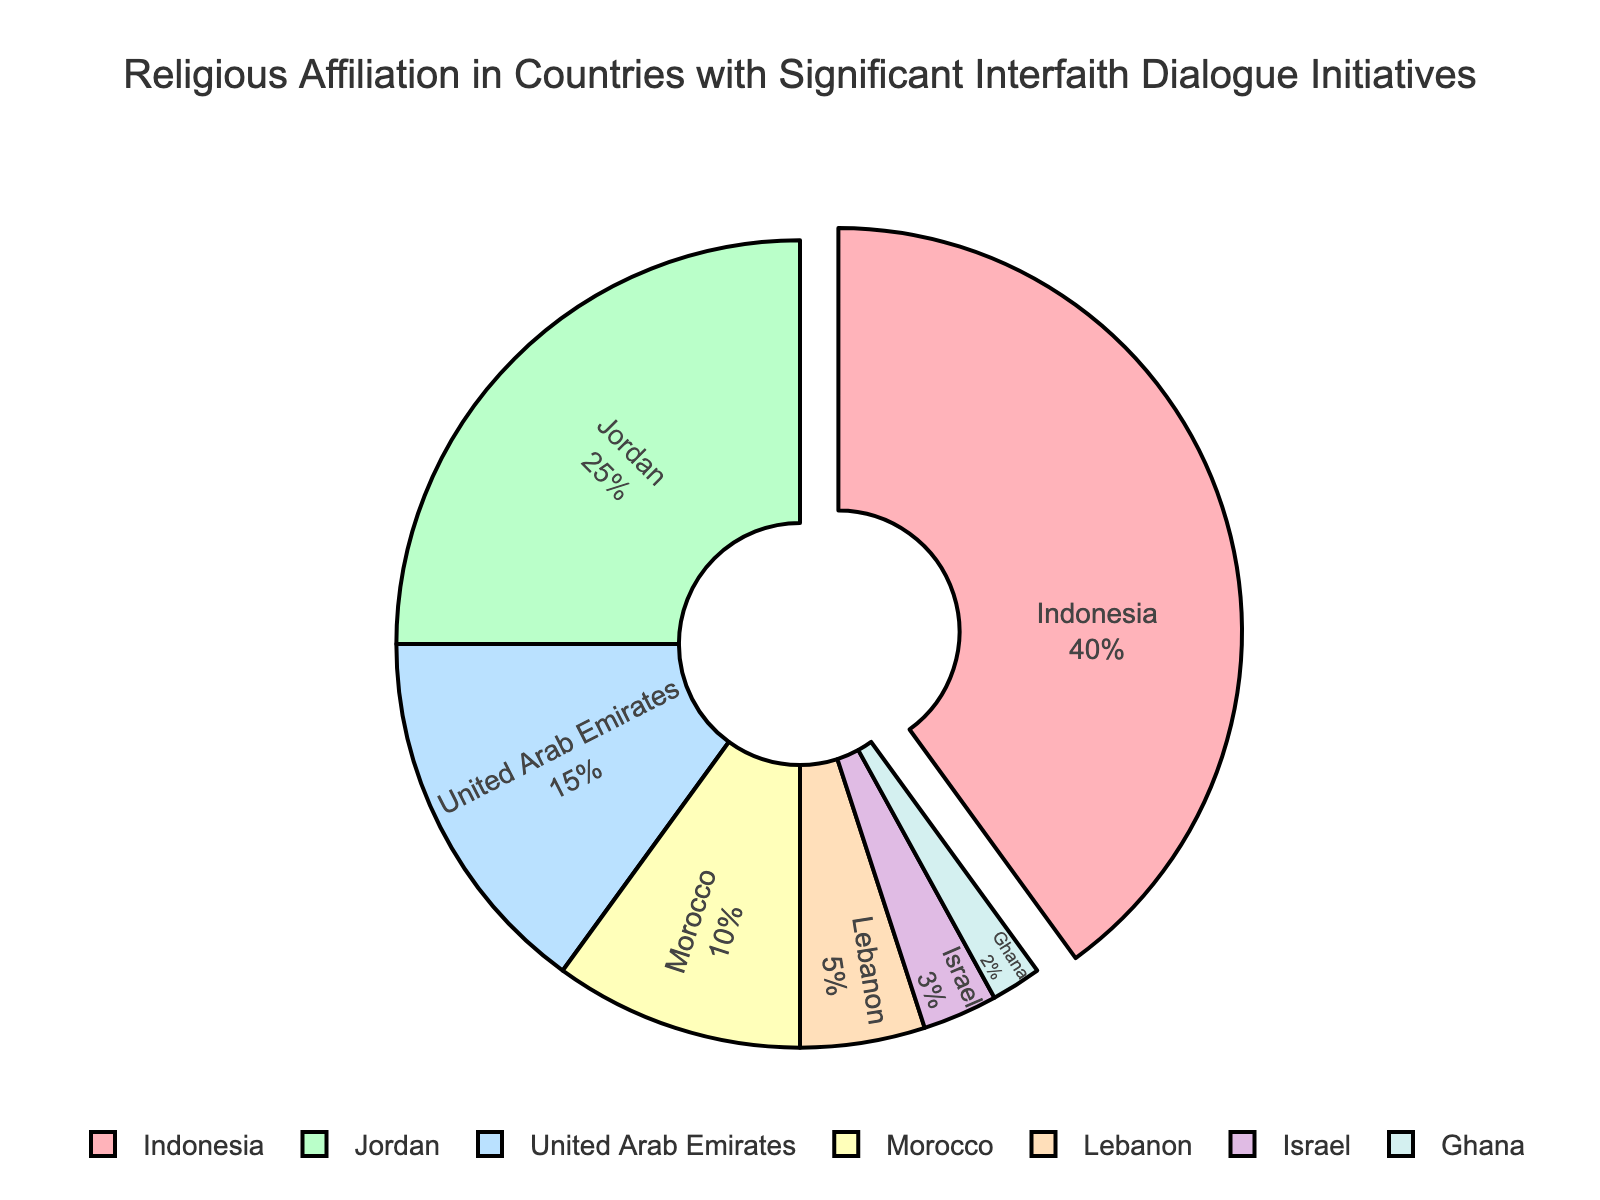Which country has the largest share of religious affiliation? The segment representing Indonesia is largest and also slightly pulled out from the pie, indicating it has the highest share of religious affiliation among the listed countries.
Answer: Indonesia What is the combined percentage of religious affiliation for Jordan and the United Arab Emirates? According to the pie chart, Jordan has 25% and the United Arab Emirates has 15%. Adding these percentages, 25% + 15% = 40%.
Answer: 40% Is the percentage of religious affiliation in Israel greater than that in Lebanon? By comparing the segments, Israel has 3% while Lebanon has 5%. Clearly, 3% is less than 5%.
Answer: No What is the difference in the percentage of religious affiliation between Morocco and Lebanon? The percentages for Morocco and Lebanon are 10% and 5% respectively. The difference is 10% - 5% = 5%.
Answer: 5% Which country has the smallest share of religious affiliation? The smallest segment in the pie chart, representing 2%, is attributed to Ghana.
Answer: Ghana Which country's segment is shown in light blue? The chart keys light blue to the segment representing the United Arab Emirates.
Answer: United Arab Emirates What is the total percentage of religious affiliation for countries with less than 5% share each? Lebanon has 5%, Israel has 3%, and Ghana has 2%. Adding these, 5% + 3% + 2% = 10%.
Answer: 10% How does the percentage of religious affiliation in Jordan compare to that in Morocco and Lebanon combined? Jordan has 25%, while Morocco and Lebanon combined have 10% + 5% = 15%. 25% is greater than 15%.
Answer: Greater What is the average percentage of religious affiliation for Indonesia, Jordan, and the United Arab Emirates? The percentages are 40%, 25%, and 15%. The average is (40 + 25 + 15) / 3 = 80 / 3 ≈ 26.67%.
Answer: ≈ 26.67% 